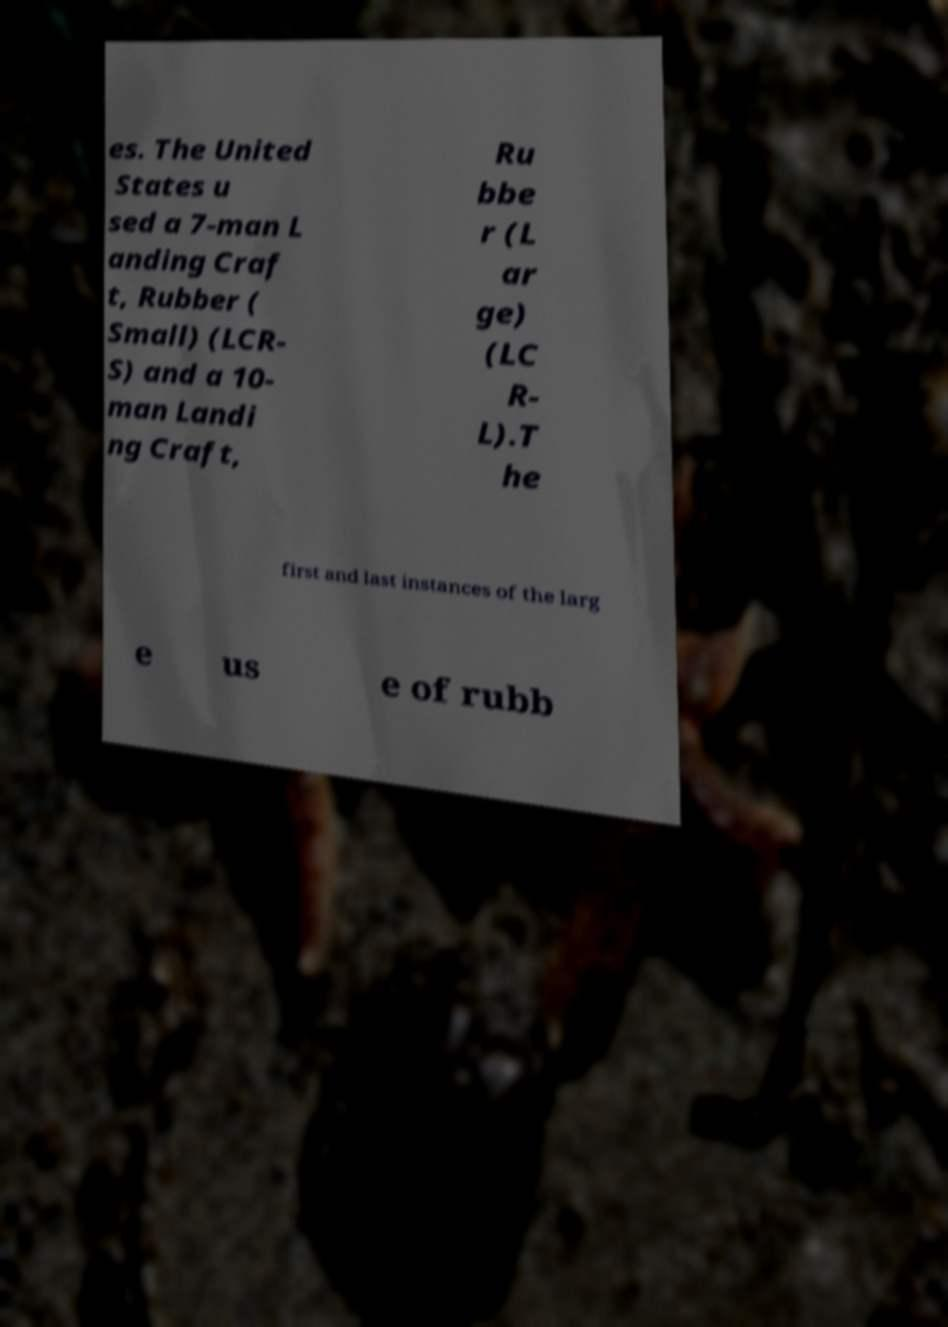Could you extract and type out the text from this image? es. The United States u sed a 7-man L anding Craf t, Rubber ( Small) (LCR- S) and a 10- man Landi ng Craft, Ru bbe r (L ar ge) (LC R- L).T he first and last instances of the larg e us e of rubb 